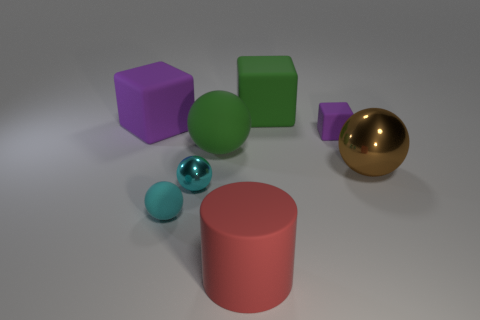Subtract all purple balls. Subtract all blue cylinders. How many balls are left? 4 Add 2 green matte things. How many objects exist? 10 Subtract all cylinders. How many objects are left? 7 Subtract all tiny cyan rubber balls. Subtract all red blocks. How many objects are left? 7 Add 3 tiny cyan matte balls. How many tiny cyan matte balls are left? 4 Add 3 small red shiny objects. How many small red shiny objects exist? 3 Subtract 0 brown cubes. How many objects are left? 8 